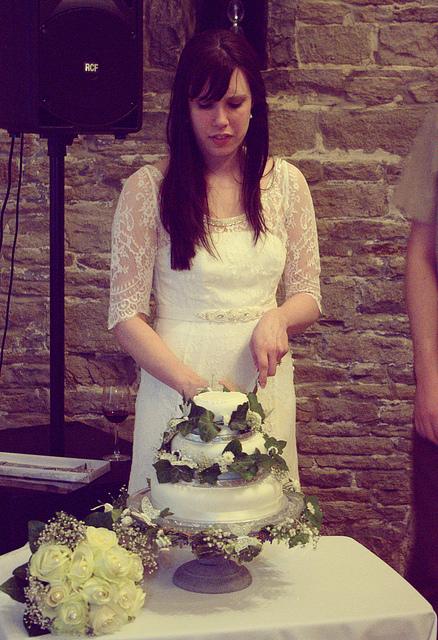What color is the brides dress?
Be succinct. White. What direction is the woman looking?
Write a very short answer. Down. What are the white things stacked up?
Concise answer only. Cake. How many flowers in the bouquet?
Keep it brief. 12. What is the bride doing?
Write a very short answer. Cutting cake. 